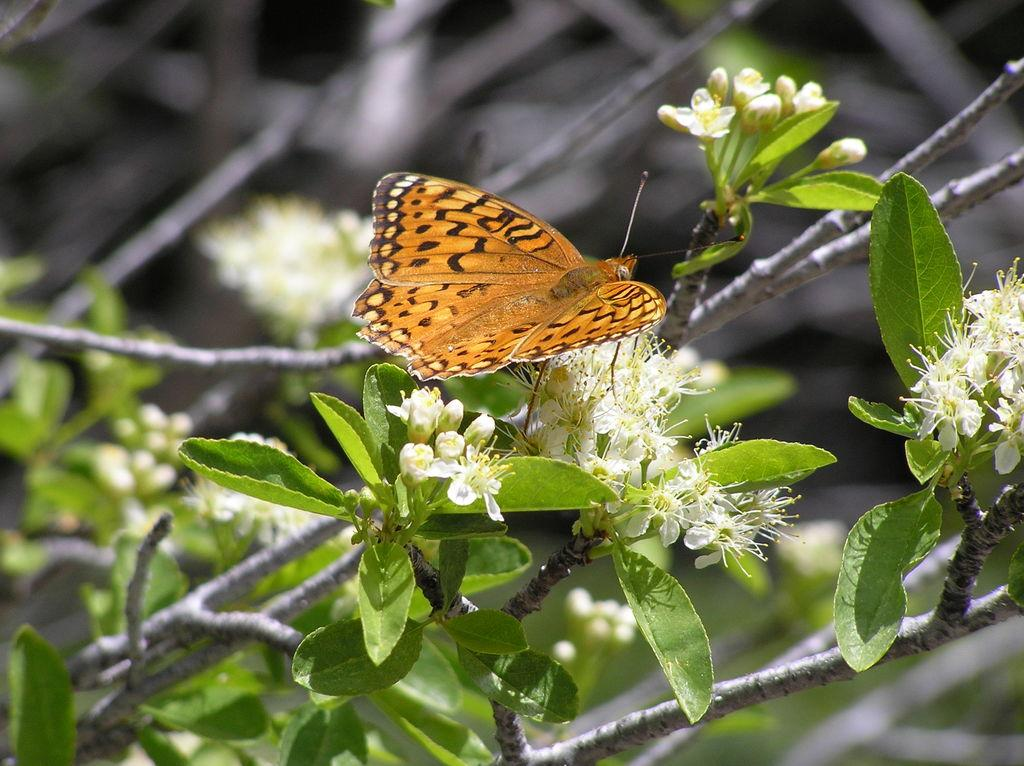What is the main subject of the image? There is a butterfly in the image. Where is the butterfly located? The butterfly is on flowers. Can you describe the plant in the image? The image contains a plant with leaves, branches, and flowers. What color are the flowers? The flowers are white in color. How would you describe the background of the image? The background of the image appears blurry. Can you tell me how many babies are crawling on the icicle in the image? There is no baby or icicle present in the image; it features a butterfly on white flowers. 